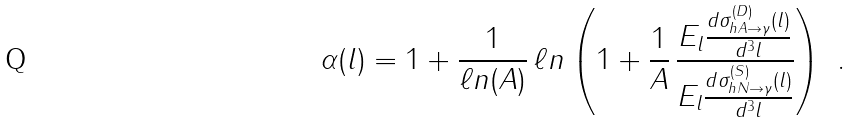<formula> <loc_0><loc_0><loc_500><loc_500>\alpha ( l ) = 1 + \frac { 1 } { \ell n ( A ) } \, \ell n \left ( 1 + \frac { 1 } { A } \, \frac { E _ { l } \frac { d \sigma ^ { ( D ) } _ { h A \rightarrow \gamma } ( l ) } { d ^ { 3 } l } } { E _ { l } \frac { d \sigma ^ { ( S ) } _ { h N \rightarrow \gamma } ( l ) } { d ^ { 3 } l } } \right ) \ .</formula> 